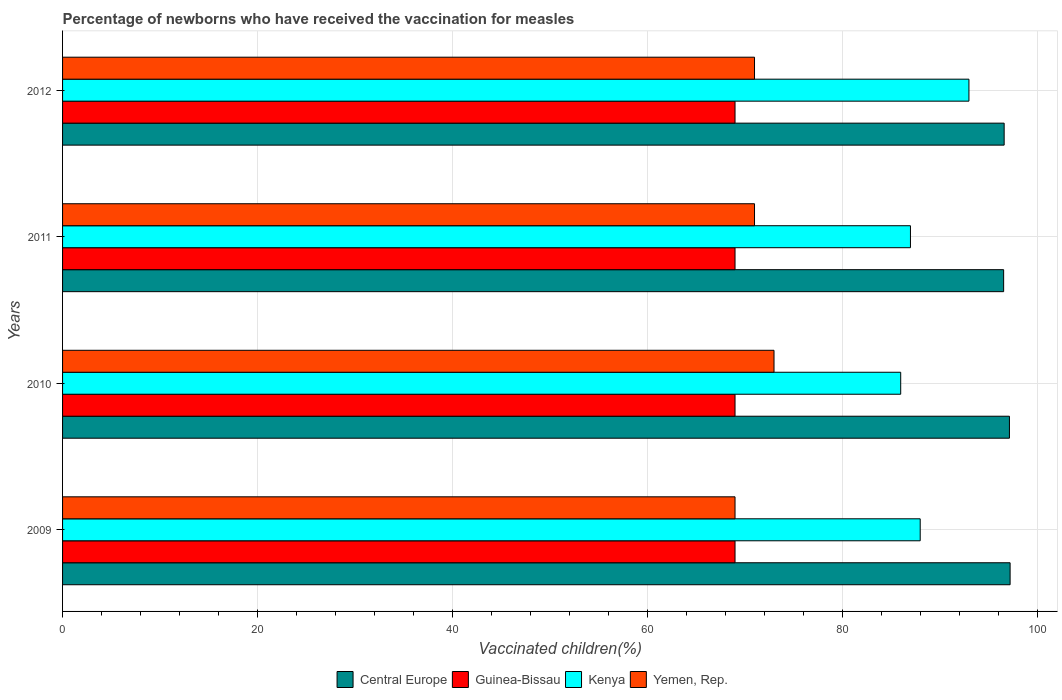How many groups of bars are there?
Your answer should be compact. 4. Are the number of bars per tick equal to the number of legend labels?
Make the answer very short. Yes. Are the number of bars on each tick of the Y-axis equal?
Make the answer very short. Yes. In how many cases, is the number of bars for a given year not equal to the number of legend labels?
Offer a very short reply. 0. What is the percentage of vaccinated children in Yemen, Rep. in 2012?
Provide a short and direct response. 71. Across all years, what is the maximum percentage of vaccinated children in Kenya?
Your answer should be compact. 93. Across all years, what is the minimum percentage of vaccinated children in Central Europe?
Your answer should be compact. 96.56. In which year was the percentage of vaccinated children in Kenya maximum?
Your answer should be compact. 2012. What is the total percentage of vaccinated children in Guinea-Bissau in the graph?
Your answer should be very brief. 276. What is the difference between the percentage of vaccinated children in Central Europe in 2010 and that in 2011?
Offer a very short reply. 0.6. What is the difference between the percentage of vaccinated children in Central Europe in 2010 and the percentage of vaccinated children in Yemen, Rep. in 2009?
Offer a terse response. 28.16. What is the average percentage of vaccinated children in Yemen, Rep. per year?
Provide a short and direct response. 71. In the year 2011, what is the difference between the percentage of vaccinated children in Central Europe and percentage of vaccinated children in Guinea-Bissau?
Keep it short and to the point. 27.56. Is the percentage of vaccinated children in Central Europe in 2010 less than that in 2012?
Provide a short and direct response. No. Is the difference between the percentage of vaccinated children in Central Europe in 2010 and 2012 greater than the difference between the percentage of vaccinated children in Guinea-Bissau in 2010 and 2012?
Ensure brevity in your answer.  Yes. What is the difference between the highest and the second highest percentage of vaccinated children in Kenya?
Your answer should be compact. 5. In how many years, is the percentage of vaccinated children in Central Europe greater than the average percentage of vaccinated children in Central Europe taken over all years?
Provide a succinct answer. 2. Is the sum of the percentage of vaccinated children in Central Europe in 2010 and 2011 greater than the maximum percentage of vaccinated children in Kenya across all years?
Ensure brevity in your answer.  Yes. What does the 3rd bar from the top in 2012 represents?
Your answer should be compact. Guinea-Bissau. What does the 3rd bar from the bottom in 2009 represents?
Keep it short and to the point. Kenya. How many bars are there?
Give a very brief answer. 16. How many years are there in the graph?
Give a very brief answer. 4. Are the values on the major ticks of X-axis written in scientific E-notation?
Make the answer very short. No. Does the graph contain any zero values?
Keep it short and to the point. No. Does the graph contain grids?
Offer a terse response. Yes. Where does the legend appear in the graph?
Offer a very short reply. Bottom center. How many legend labels are there?
Provide a short and direct response. 4. How are the legend labels stacked?
Your answer should be very brief. Horizontal. What is the title of the graph?
Your answer should be compact. Percentage of newborns who have received the vaccination for measles. What is the label or title of the X-axis?
Provide a short and direct response. Vaccinated children(%). What is the label or title of the Y-axis?
Offer a terse response. Years. What is the Vaccinated children(%) of Central Europe in 2009?
Your answer should be compact. 97.23. What is the Vaccinated children(%) of Kenya in 2009?
Your answer should be very brief. 88. What is the Vaccinated children(%) in Yemen, Rep. in 2009?
Provide a succinct answer. 69. What is the Vaccinated children(%) of Central Europe in 2010?
Give a very brief answer. 97.16. What is the Vaccinated children(%) of Guinea-Bissau in 2010?
Provide a succinct answer. 69. What is the Vaccinated children(%) of Kenya in 2010?
Provide a succinct answer. 86. What is the Vaccinated children(%) in Central Europe in 2011?
Provide a short and direct response. 96.56. What is the Vaccinated children(%) of Kenya in 2011?
Your answer should be very brief. 87. What is the Vaccinated children(%) of Central Europe in 2012?
Your answer should be very brief. 96.61. What is the Vaccinated children(%) in Kenya in 2012?
Provide a succinct answer. 93. What is the Vaccinated children(%) in Yemen, Rep. in 2012?
Ensure brevity in your answer.  71. Across all years, what is the maximum Vaccinated children(%) in Central Europe?
Your response must be concise. 97.23. Across all years, what is the maximum Vaccinated children(%) in Guinea-Bissau?
Make the answer very short. 69. Across all years, what is the maximum Vaccinated children(%) of Kenya?
Your answer should be compact. 93. Across all years, what is the maximum Vaccinated children(%) in Yemen, Rep.?
Give a very brief answer. 73. Across all years, what is the minimum Vaccinated children(%) of Central Europe?
Your answer should be compact. 96.56. Across all years, what is the minimum Vaccinated children(%) of Guinea-Bissau?
Your answer should be very brief. 69. Across all years, what is the minimum Vaccinated children(%) in Kenya?
Offer a terse response. 86. What is the total Vaccinated children(%) in Central Europe in the graph?
Make the answer very short. 387.56. What is the total Vaccinated children(%) in Guinea-Bissau in the graph?
Your answer should be very brief. 276. What is the total Vaccinated children(%) in Kenya in the graph?
Offer a very short reply. 354. What is the total Vaccinated children(%) of Yemen, Rep. in the graph?
Ensure brevity in your answer.  284. What is the difference between the Vaccinated children(%) of Central Europe in 2009 and that in 2010?
Your answer should be very brief. 0.07. What is the difference between the Vaccinated children(%) in Yemen, Rep. in 2009 and that in 2010?
Offer a terse response. -4. What is the difference between the Vaccinated children(%) in Central Europe in 2009 and that in 2011?
Your answer should be compact. 0.67. What is the difference between the Vaccinated children(%) of Kenya in 2009 and that in 2011?
Offer a very short reply. 1. What is the difference between the Vaccinated children(%) of Central Europe in 2009 and that in 2012?
Keep it short and to the point. 0.61. What is the difference between the Vaccinated children(%) of Guinea-Bissau in 2009 and that in 2012?
Your answer should be very brief. 0. What is the difference between the Vaccinated children(%) of Kenya in 2009 and that in 2012?
Give a very brief answer. -5. What is the difference between the Vaccinated children(%) of Yemen, Rep. in 2009 and that in 2012?
Provide a short and direct response. -2. What is the difference between the Vaccinated children(%) in Central Europe in 2010 and that in 2011?
Your response must be concise. 0.6. What is the difference between the Vaccinated children(%) of Guinea-Bissau in 2010 and that in 2011?
Make the answer very short. 0. What is the difference between the Vaccinated children(%) in Yemen, Rep. in 2010 and that in 2011?
Provide a succinct answer. 2. What is the difference between the Vaccinated children(%) in Central Europe in 2010 and that in 2012?
Your answer should be very brief. 0.54. What is the difference between the Vaccinated children(%) in Guinea-Bissau in 2010 and that in 2012?
Provide a short and direct response. 0. What is the difference between the Vaccinated children(%) in Kenya in 2010 and that in 2012?
Keep it short and to the point. -7. What is the difference between the Vaccinated children(%) in Yemen, Rep. in 2010 and that in 2012?
Provide a succinct answer. 2. What is the difference between the Vaccinated children(%) in Central Europe in 2011 and that in 2012?
Your answer should be compact. -0.05. What is the difference between the Vaccinated children(%) of Guinea-Bissau in 2011 and that in 2012?
Your answer should be compact. 0. What is the difference between the Vaccinated children(%) of Central Europe in 2009 and the Vaccinated children(%) of Guinea-Bissau in 2010?
Give a very brief answer. 28.23. What is the difference between the Vaccinated children(%) of Central Europe in 2009 and the Vaccinated children(%) of Kenya in 2010?
Your answer should be compact. 11.23. What is the difference between the Vaccinated children(%) of Central Europe in 2009 and the Vaccinated children(%) of Yemen, Rep. in 2010?
Your response must be concise. 24.23. What is the difference between the Vaccinated children(%) of Guinea-Bissau in 2009 and the Vaccinated children(%) of Kenya in 2010?
Your answer should be very brief. -17. What is the difference between the Vaccinated children(%) of Guinea-Bissau in 2009 and the Vaccinated children(%) of Yemen, Rep. in 2010?
Give a very brief answer. -4. What is the difference between the Vaccinated children(%) in Central Europe in 2009 and the Vaccinated children(%) in Guinea-Bissau in 2011?
Provide a short and direct response. 28.23. What is the difference between the Vaccinated children(%) of Central Europe in 2009 and the Vaccinated children(%) of Kenya in 2011?
Your response must be concise. 10.23. What is the difference between the Vaccinated children(%) in Central Europe in 2009 and the Vaccinated children(%) in Yemen, Rep. in 2011?
Ensure brevity in your answer.  26.23. What is the difference between the Vaccinated children(%) of Central Europe in 2009 and the Vaccinated children(%) of Guinea-Bissau in 2012?
Provide a short and direct response. 28.23. What is the difference between the Vaccinated children(%) of Central Europe in 2009 and the Vaccinated children(%) of Kenya in 2012?
Offer a very short reply. 4.23. What is the difference between the Vaccinated children(%) of Central Europe in 2009 and the Vaccinated children(%) of Yemen, Rep. in 2012?
Your answer should be compact. 26.23. What is the difference between the Vaccinated children(%) of Guinea-Bissau in 2009 and the Vaccinated children(%) of Kenya in 2012?
Keep it short and to the point. -24. What is the difference between the Vaccinated children(%) in Central Europe in 2010 and the Vaccinated children(%) in Guinea-Bissau in 2011?
Your response must be concise. 28.16. What is the difference between the Vaccinated children(%) in Central Europe in 2010 and the Vaccinated children(%) in Kenya in 2011?
Provide a short and direct response. 10.16. What is the difference between the Vaccinated children(%) in Central Europe in 2010 and the Vaccinated children(%) in Yemen, Rep. in 2011?
Your response must be concise. 26.16. What is the difference between the Vaccinated children(%) in Guinea-Bissau in 2010 and the Vaccinated children(%) in Yemen, Rep. in 2011?
Your answer should be very brief. -2. What is the difference between the Vaccinated children(%) of Kenya in 2010 and the Vaccinated children(%) of Yemen, Rep. in 2011?
Your response must be concise. 15. What is the difference between the Vaccinated children(%) of Central Europe in 2010 and the Vaccinated children(%) of Guinea-Bissau in 2012?
Keep it short and to the point. 28.16. What is the difference between the Vaccinated children(%) of Central Europe in 2010 and the Vaccinated children(%) of Kenya in 2012?
Your answer should be compact. 4.16. What is the difference between the Vaccinated children(%) in Central Europe in 2010 and the Vaccinated children(%) in Yemen, Rep. in 2012?
Keep it short and to the point. 26.16. What is the difference between the Vaccinated children(%) of Guinea-Bissau in 2010 and the Vaccinated children(%) of Kenya in 2012?
Make the answer very short. -24. What is the difference between the Vaccinated children(%) of Central Europe in 2011 and the Vaccinated children(%) of Guinea-Bissau in 2012?
Offer a terse response. 27.56. What is the difference between the Vaccinated children(%) of Central Europe in 2011 and the Vaccinated children(%) of Kenya in 2012?
Offer a very short reply. 3.56. What is the difference between the Vaccinated children(%) in Central Europe in 2011 and the Vaccinated children(%) in Yemen, Rep. in 2012?
Your answer should be very brief. 25.56. What is the average Vaccinated children(%) in Central Europe per year?
Keep it short and to the point. 96.89. What is the average Vaccinated children(%) of Kenya per year?
Your answer should be compact. 88.5. In the year 2009, what is the difference between the Vaccinated children(%) in Central Europe and Vaccinated children(%) in Guinea-Bissau?
Offer a terse response. 28.23. In the year 2009, what is the difference between the Vaccinated children(%) in Central Europe and Vaccinated children(%) in Kenya?
Offer a terse response. 9.23. In the year 2009, what is the difference between the Vaccinated children(%) of Central Europe and Vaccinated children(%) of Yemen, Rep.?
Your response must be concise. 28.23. In the year 2009, what is the difference between the Vaccinated children(%) in Guinea-Bissau and Vaccinated children(%) in Kenya?
Offer a very short reply. -19. In the year 2009, what is the difference between the Vaccinated children(%) of Guinea-Bissau and Vaccinated children(%) of Yemen, Rep.?
Provide a succinct answer. 0. In the year 2010, what is the difference between the Vaccinated children(%) in Central Europe and Vaccinated children(%) in Guinea-Bissau?
Your response must be concise. 28.16. In the year 2010, what is the difference between the Vaccinated children(%) in Central Europe and Vaccinated children(%) in Kenya?
Provide a succinct answer. 11.16. In the year 2010, what is the difference between the Vaccinated children(%) in Central Europe and Vaccinated children(%) in Yemen, Rep.?
Your answer should be very brief. 24.16. In the year 2010, what is the difference between the Vaccinated children(%) of Guinea-Bissau and Vaccinated children(%) of Kenya?
Provide a succinct answer. -17. In the year 2010, what is the difference between the Vaccinated children(%) in Kenya and Vaccinated children(%) in Yemen, Rep.?
Offer a terse response. 13. In the year 2011, what is the difference between the Vaccinated children(%) of Central Europe and Vaccinated children(%) of Guinea-Bissau?
Provide a succinct answer. 27.56. In the year 2011, what is the difference between the Vaccinated children(%) of Central Europe and Vaccinated children(%) of Kenya?
Offer a very short reply. 9.56. In the year 2011, what is the difference between the Vaccinated children(%) in Central Europe and Vaccinated children(%) in Yemen, Rep.?
Offer a very short reply. 25.56. In the year 2012, what is the difference between the Vaccinated children(%) in Central Europe and Vaccinated children(%) in Guinea-Bissau?
Your answer should be very brief. 27.61. In the year 2012, what is the difference between the Vaccinated children(%) of Central Europe and Vaccinated children(%) of Kenya?
Provide a succinct answer. 3.61. In the year 2012, what is the difference between the Vaccinated children(%) of Central Europe and Vaccinated children(%) of Yemen, Rep.?
Give a very brief answer. 25.61. In the year 2012, what is the difference between the Vaccinated children(%) in Guinea-Bissau and Vaccinated children(%) in Kenya?
Your answer should be very brief. -24. In the year 2012, what is the difference between the Vaccinated children(%) of Guinea-Bissau and Vaccinated children(%) of Yemen, Rep.?
Your response must be concise. -2. What is the ratio of the Vaccinated children(%) of Central Europe in 2009 to that in 2010?
Provide a short and direct response. 1. What is the ratio of the Vaccinated children(%) of Guinea-Bissau in 2009 to that in 2010?
Offer a terse response. 1. What is the ratio of the Vaccinated children(%) in Kenya in 2009 to that in 2010?
Provide a succinct answer. 1.02. What is the ratio of the Vaccinated children(%) in Yemen, Rep. in 2009 to that in 2010?
Ensure brevity in your answer.  0.95. What is the ratio of the Vaccinated children(%) in Central Europe in 2009 to that in 2011?
Provide a short and direct response. 1.01. What is the ratio of the Vaccinated children(%) in Kenya in 2009 to that in 2011?
Your response must be concise. 1.01. What is the ratio of the Vaccinated children(%) of Yemen, Rep. in 2009 to that in 2011?
Your answer should be compact. 0.97. What is the ratio of the Vaccinated children(%) of Guinea-Bissau in 2009 to that in 2012?
Your answer should be compact. 1. What is the ratio of the Vaccinated children(%) of Kenya in 2009 to that in 2012?
Provide a short and direct response. 0.95. What is the ratio of the Vaccinated children(%) in Yemen, Rep. in 2009 to that in 2012?
Your answer should be compact. 0.97. What is the ratio of the Vaccinated children(%) in Central Europe in 2010 to that in 2011?
Provide a succinct answer. 1.01. What is the ratio of the Vaccinated children(%) in Yemen, Rep. in 2010 to that in 2011?
Ensure brevity in your answer.  1.03. What is the ratio of the Vaccinated children(%) in Central Europe in 2010 to that in 2012?
Ensure brevity in your answer.  1.01. What is the ratio of the Vaccinated children(%) of Guinea-Bissau in 2010 to that in 2012?
Your response must be concise. 1. What is the ratio of the Vaccinated children(%) in Kenya in 2010 to that in 2012?
Make the answer very short. 0.92. What is the ratio of the Vaccinated children(%) of Yemen, Rep. in 2010 to that in 2012?
Give a very brief answer. 1.03. What is the ratio of the Vaccinated children(%) in Kenya in 2011 to that in 2012?
Provide a short and direct response. 0.94. What is the difference between the highest and the second highest Vaccinated children(%) of Central Europe?
Provide a short and direct response. 0.07. What is the difference between the highest and the second highest Vaccinated children(%) of Guinea-Bissau?
Your answer should be compact. 0. What is the difference between the highest and the second highest Vaccinated children(%) of Kenya?
Give a very brief answer. 5. What is the difference between the highest and the second highest Vaccinated children(%) of Yemen, Rep.?
Provide a succinct answer. 2. What is the difference between the highest and the lowest Vaccinated children(%) of Central Europe?
Give a very brief answer. 0.67. What is the difference between the highest and the lowest Vaccinated children(%) in Guinea-Bissau?
Provide a succinct answer. 0. What is the difference between the highest and the lowest Vaccinated children(%) in Kenya?
Offer a very short reply. 7. 